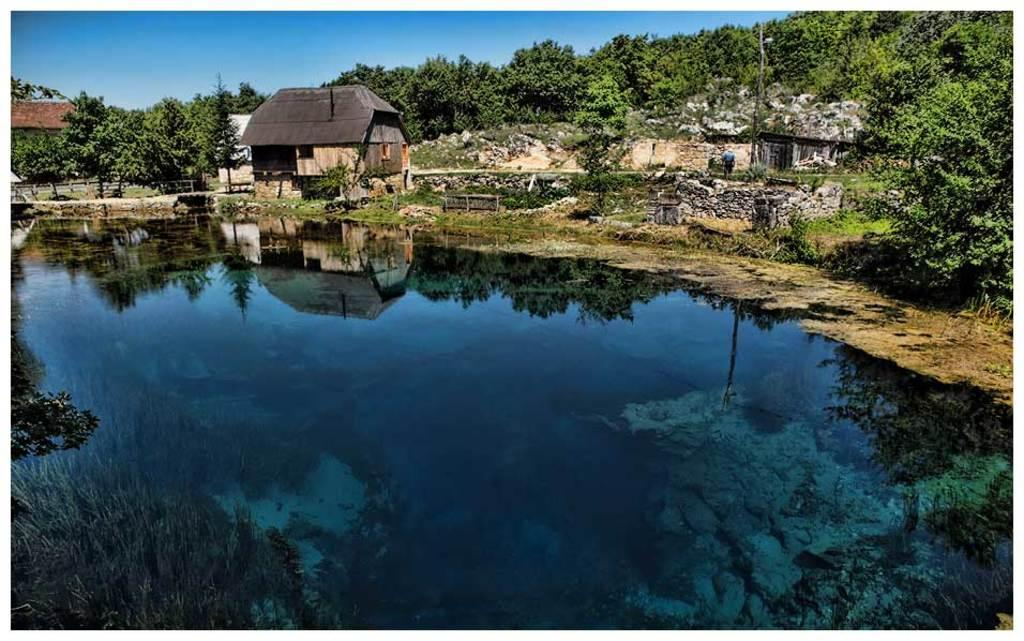What is at the bottom of the image? There is water at the bottom of the image. What can be seen behind the water? There are many trees behind the water. What type of structures are present in the image? Stone walls and a building with a roof are visible in the image. What else can be seen in the image? Poles are visible in the image. What is visible at the top of the image? The sky is visible at the top of the image. What invention is being demonstrated by the kettle in the image? There is no kettle present in the image, so no invention can be demonstrated. What mark can be seen on the building in the image? There is no specific mark mentioned or visible on the building in the image. 